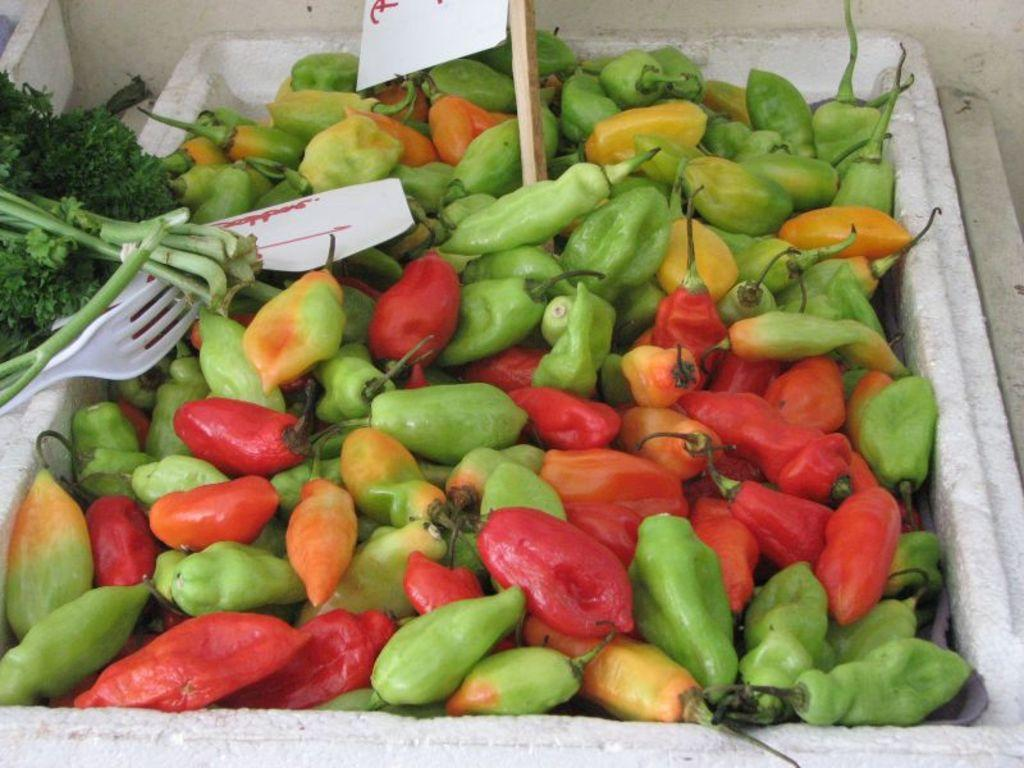What type of food ingredients are present in the image? There are chillies and coriander leaves in the image. What else can be seen in the image besides food ingredients? There are posters and a fork visible in the image. What is the wooden object in the box in the image? There is a wooden pole in a box in the image. Where is the nearest library to the location depicted in the image? The image does not provide any information about the location or the presence of a library, so it cannot be determined from the image. 